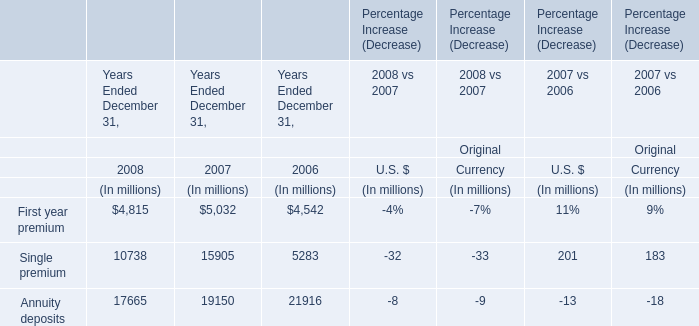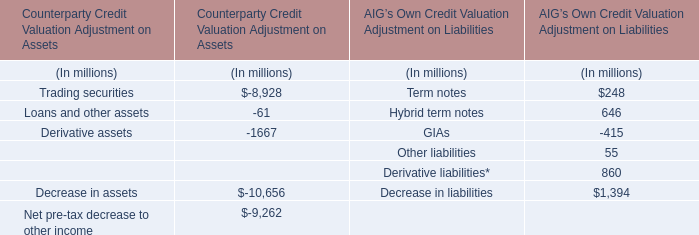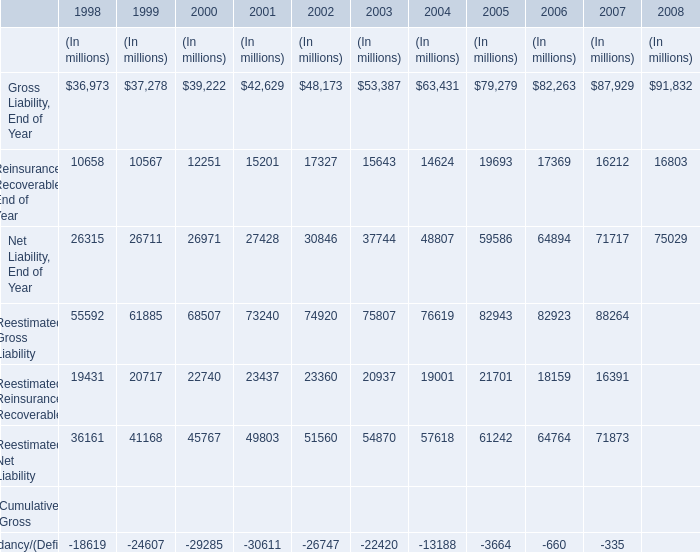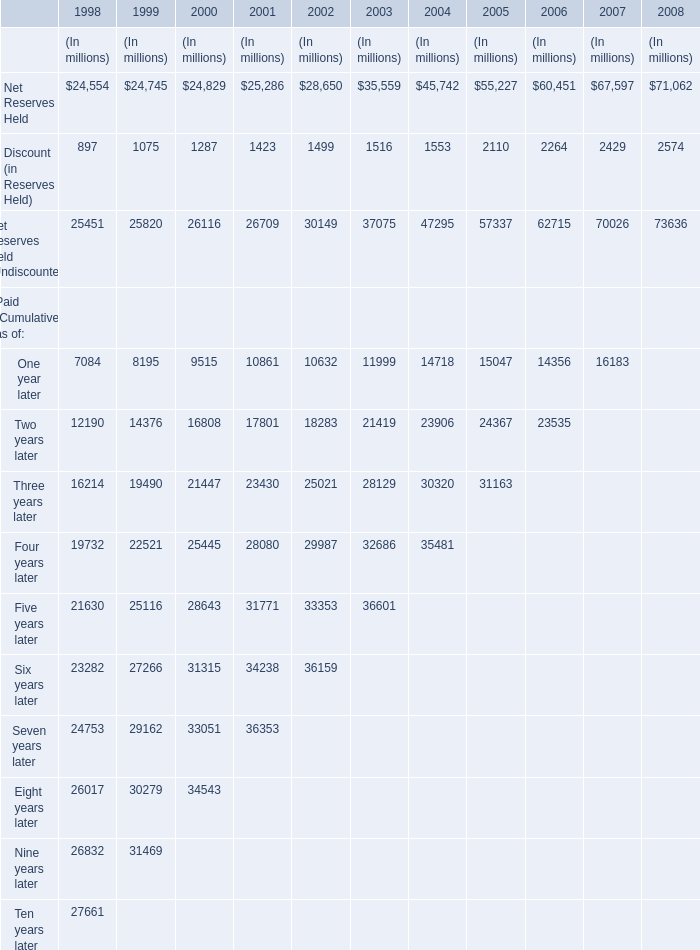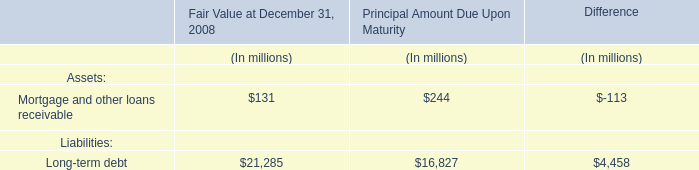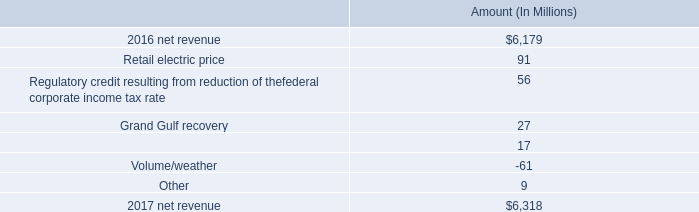What's the average of Net Reserves Held and Discount (in Reserves Held) and Net Reserves Held (Undiscounted) in 1998? (in million) 
Computations: (((24554 + 897) + 25451) / 3)
Answer: 16967.33333. 